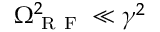Convert formula to latex. <formula><loc_0><loc_0><loc_500><loc_500>\Omega _ { R F } ^ { 2 } \ll \gamma ^ { 2 }</formula> 